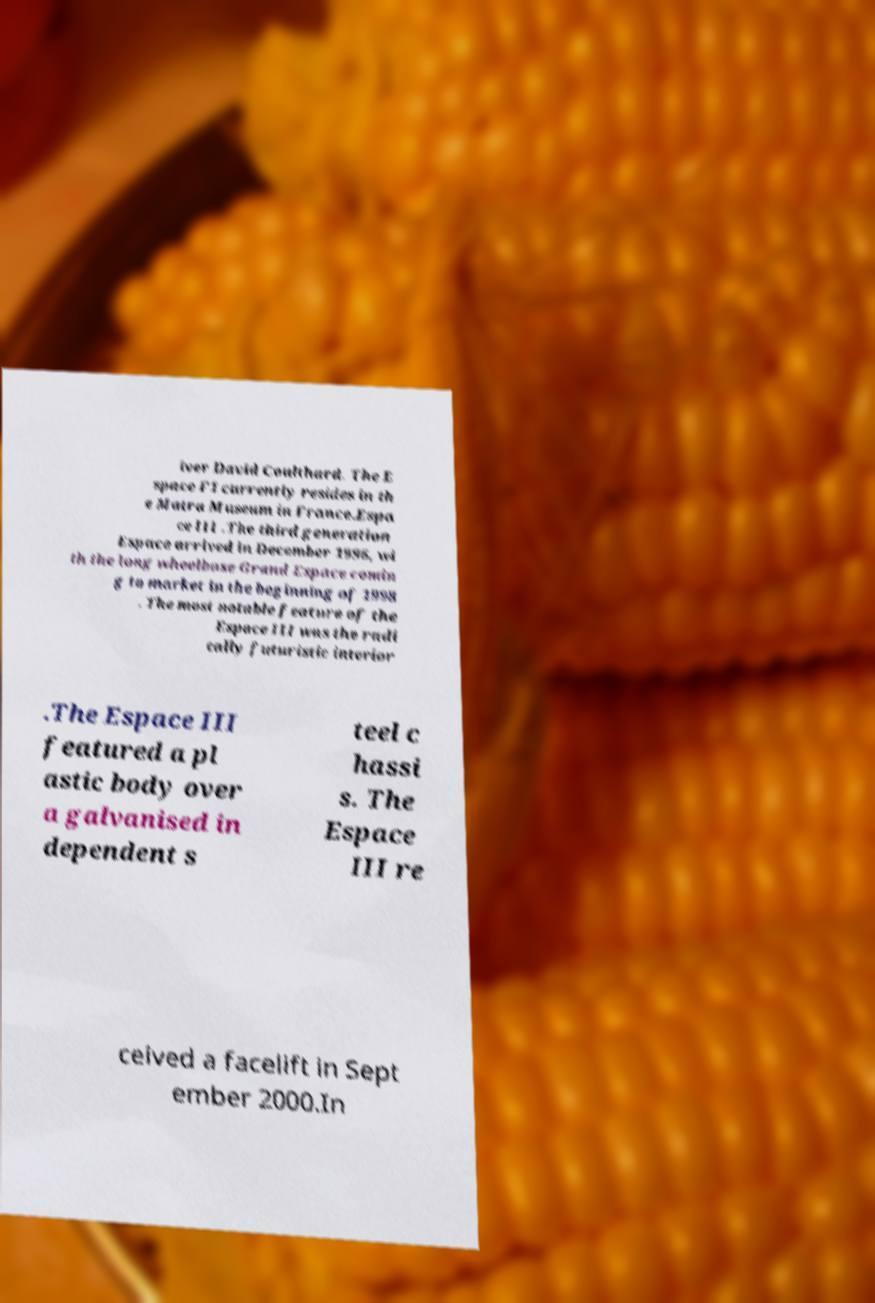For documentation purposes, I need the text within this image transcribed. Could you provide that? iver David Coulthard. The E space F1 currently resides in th e Matra Museum in France.Espa ce III .The third generation Espace arrived in December 1996, wi th the long wheelbase Grand Espace comin g to market in the beginning of 1998 . The most notable feature of the Espace III was the radi cally futuristic interior .The Espace III featured a pl astic body over a galvanised in dependent s teel c hassi s. The Espace III re ceived a facelift in Sept ember 2000.In 